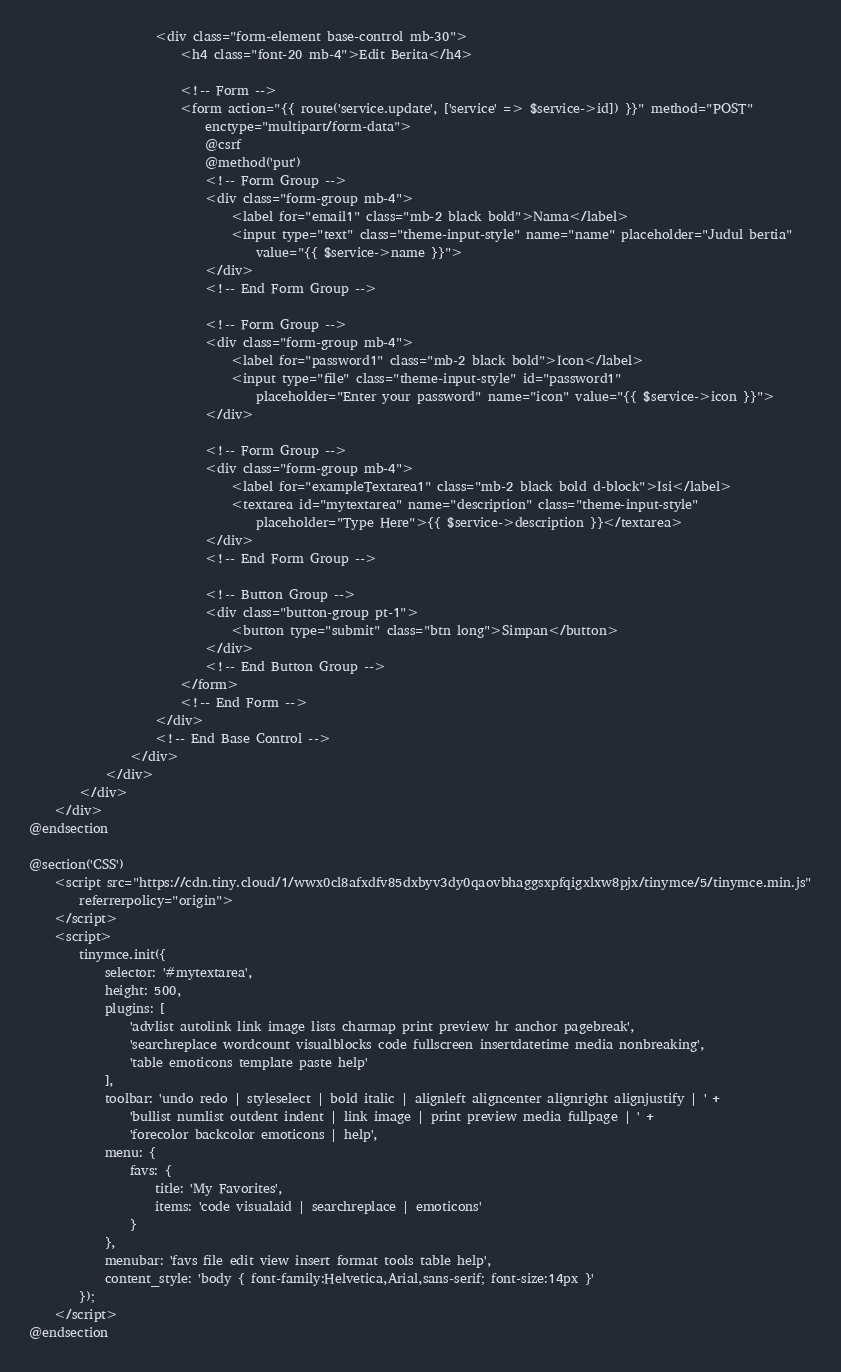<code> <loc_0><loc_0><loc_500><loc_500><_PHP_>                    <div class="form-element base-control mb-30">
                        <h4 class="font-20 mb-4">Edit Berita</h4>

                        <!-- Form -->
                        <form action="{{ route('service.update', ['service' => $service->id]) }}" method="POST"
                            enctype="multipart/form-data">
                            @csrf
                            @method('put')
                            <!-- Form Group -->
                            <div class="form-group mb-4">
                                <label for="email1" class="mb-2 black bold">Nama</label>
                                <input type="text" class="theme-input-style" name="name" placeholder="Judul bertia"
                                    value="{{ $service->name }}">
                            </div>
                            <!-- End Form Group -->

                            <!-- Form Group -->
                            <div class="form-group mb-4">
                                <label for="password1" class="mb-2 black bold">Icon</label>
                                <input type="file" class="theme-input-style" id="password1"
                                    placeholder="Enter your password" name="icon" value="{{ $service->icon }}">
                            </div>

                            <!-- Form Group -->
                            <div class="form-group mb-4">
                                <label for="exampleTextarea1" class="mb-2 black bold d-block">Isi</label>
                                <textarea id="mytextarea" name="description" class="theme-input-style"
                                    placeholder="Type Here">{{ $service->description }}</textarea>
                            </div>
                            <!-- End Form Group -->

                            <!-- Button Group -->
                            <div class="button-group pt-1">
                                <button type="submit" class="btn long">Simpan</button>
                            </div>
                            <!-- End Button Group -->
                        </form>
                        <!-- End Form -->
                    </div>
                    <!-- End Base Control -->
                </div>
            </div>
        </div>
    </div>
@endsection

@section('CSS')
    <script src="https://cdn.tiny.cloud/1/wwx0cl8afxdfv85dxbyv3dy0qaovbhaggsxpfqigxlxw8pjx/tinymce/5/tinymce.min.js"
        referrerpolicy="origin">
    </script>
    <script>
        tinymce.init({
            selector: '#mytextarea',
            height: 500,
            plugins: [
                'advlist autolink link image lists charmap print preview hr anchor pagebreak',
                'searchreplace wordcount visualblocks code fullscreen insertdatetime media nonbreaking',
                'table emoticons template paste help'
            ],
            toolbar: 'undo redo | styleselect | bold italic | alignleft aligncenter alignright alignjustify | ' +
                'bullist numlist outdent indent | link image | print preview media fullpage | ' +
                'forecolor backcolor emoticons | help',
            menu: {
                favs: {
                    title: 'My Favorites',
                    items: 'code visualaid | searchreplace | emoticons'
                }
            },
            menubar: 'favs file edit view insert format tools table help',
            content_style: 'body { font-family:Helvetica,Arial,sans-serif; font-size:14px }'
        });
    </script>
@endsection
</code> 